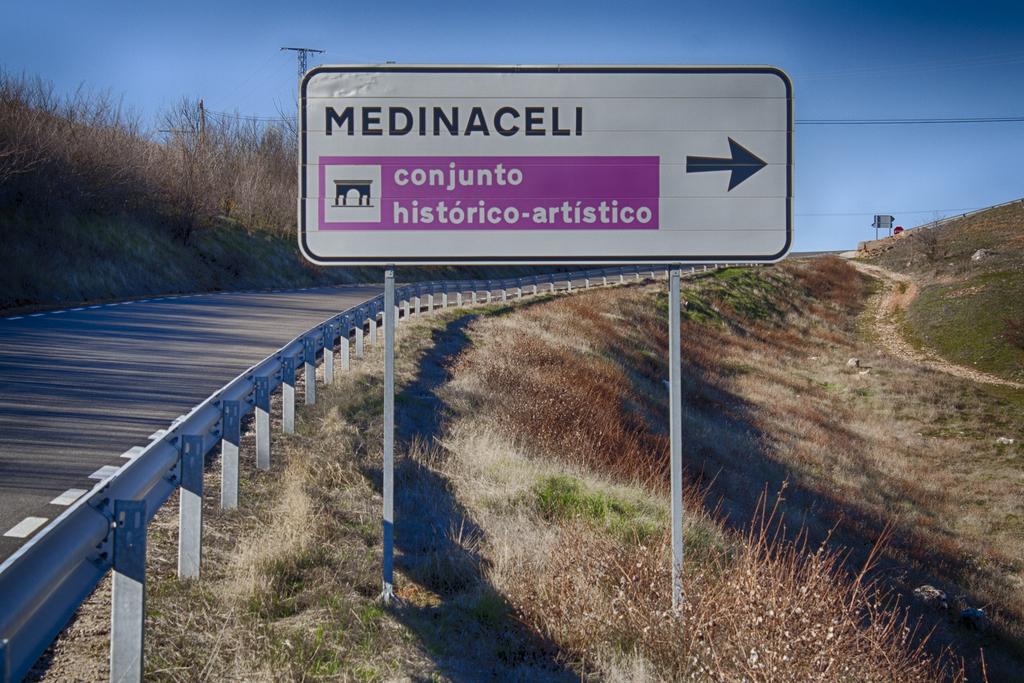What is the name on the sign?
Provide a succinct answer. Medinaceli. What is the sign pointing toward?
Your answer should be compact. Medinaceli. 